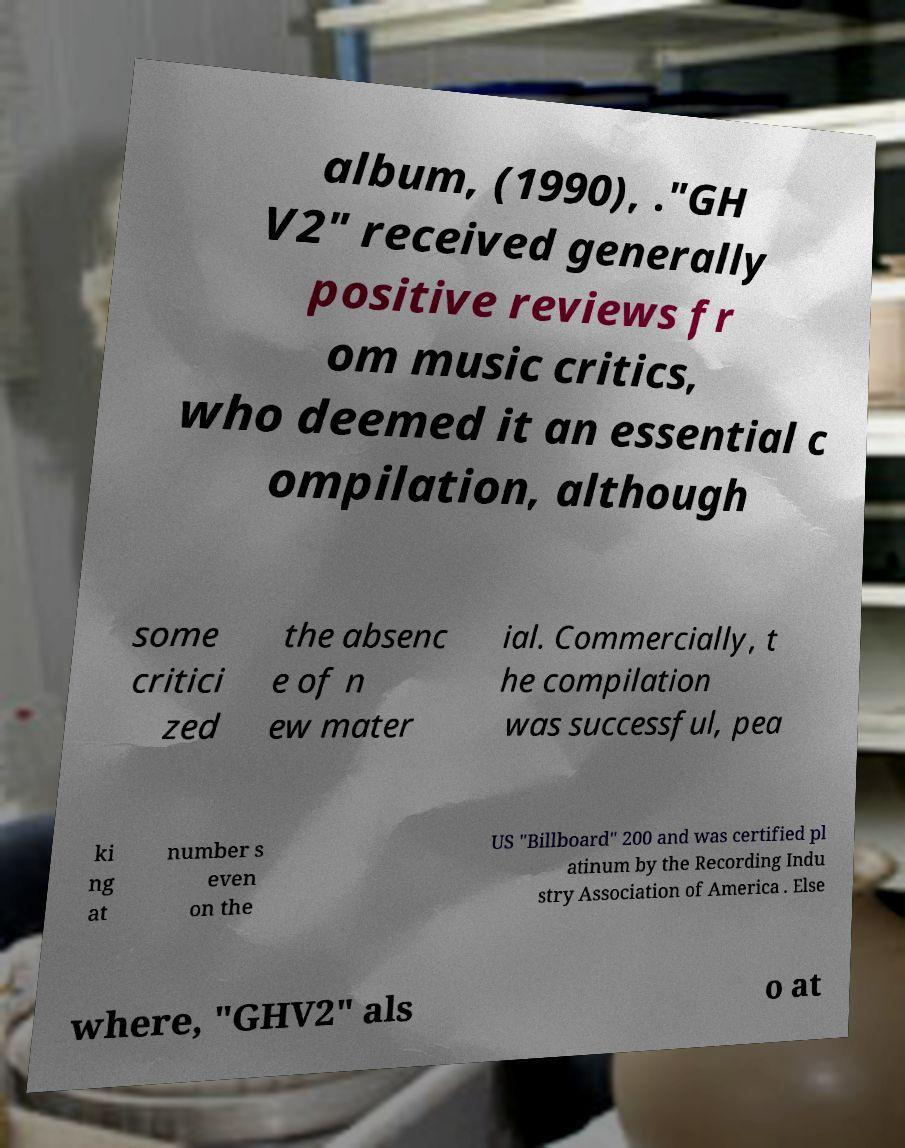Could you extract and type out the text from this image? album, (1990), ."GH V2" received generally positive reviews fr om music critics, who deemed it an essential c ompilation, although some critici zed the absenc e of n ew mater ial. Commercially, t he compilation was successful, pea ki ng at number s even on the US "Billboard" 200 and was certified pl atinum by the Recording Indu stry Association of America . Else where, "GHV2" als o at 